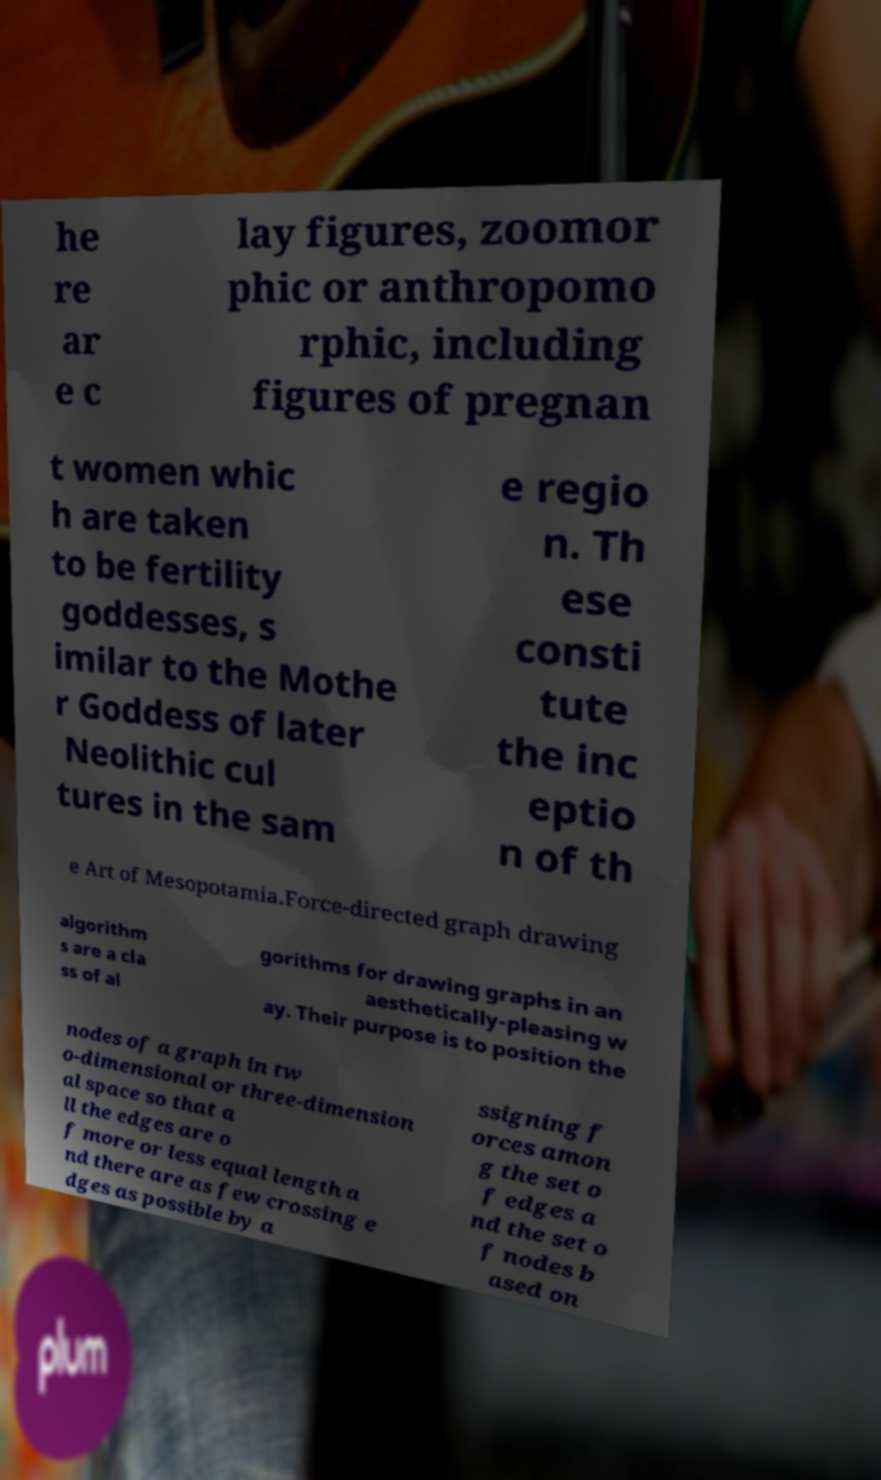Please read and relay the text visible in this image. What does it say? he re ar e c lay figures, zoomor phic or anthropomo rphic, including figures of pregnan t women whic h are taken to be fertility goddesses, s imilar to the Mothe r Goddess of later Neolithic cul tures in the sam e regio n. Th ese consti tute the inc eptio n of th e Art of Mesopotamia.Force-directed graph drawing algorithm s are a cla ss of al gorithms for drawing graphs in an aesthetically-pleasing w ay. Their purpose is to position the nodes of a graph in tw o-dimensional or three-dimension al space so that a ll the edges are o f more or less equal length a nd there are as few crossing e dges as possible by a ssigning f orces amon g the set o f edges a nd the set o f nodes b ased on 